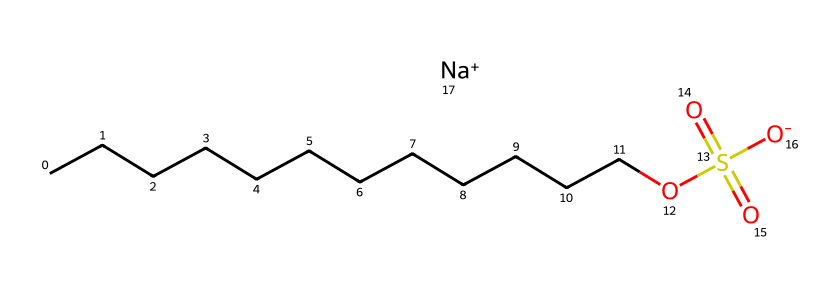What is the molecular formula of sodium lauryl sulfate? To determine the molecular formula, we can count the number of each type of atom present in the SMILES. There are 12 carbon atoms (C), 25 hydrogen atoms (H), 1 sulfur atom (S), and 4 oxygen atoms (O). Combining these gives the molecular formula C12H25NaO4S.
Answer: C12H25NaO4S How many carbon atoms are in sodium lauryl sulfate? From the SMILES representation, the long carbon chain shows 12 carbon atoms (C).
Answer: 12 What is the charge of the sodium ion in this compound? The SMILES includes "[Na+]", indicating that the sodium ion has a positive charge.
Answer: +1 What functional groups are present in sodium lauryl sulfate? Analyzing the structure, sodium lauryl sulfate contains a sulfonate group (-OS(=O)(=O)[O-]) and a long hydrocarbon chain, which acts as the hydrophobic tail.
Answer: sulfonate What is the role of sodium lauryl sulfate in detergents? Sodium lauryl sulfate serves as a surfactant in detergents, helping to reduce surface tension and allowing water to mix with oils and dirt, facilitating cleaning.
Answer: surfactant How does the structure influence the solubility of sodium lauryl sulfate? The long carbon chain makes sodium lauryl sulfate hydrophobic, while the sulfonate group is hydrophilic, allowing it to interact with both water and oils, which enhances solubility in water.
Answer: amphiphilic What type of chemical reaction is involved in forming sodium lauryl sulfate? The formation of sodium lauryl sulfate typically involves the sulfonation of lauryl alcohol, which is a condensation reaction that produces the sulfonate along with sodium.
Answer: sulfonation 